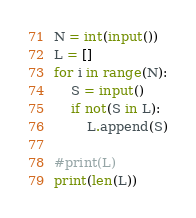Convert code to text. <code><loc_0><loc_0><loc_500><loc_500><_Python_>N = int(input())
L = []
for i in range(N):
    S = input()
    if not(S in L):
        L.append(S)

#print(L)
print(len(L))</code> 